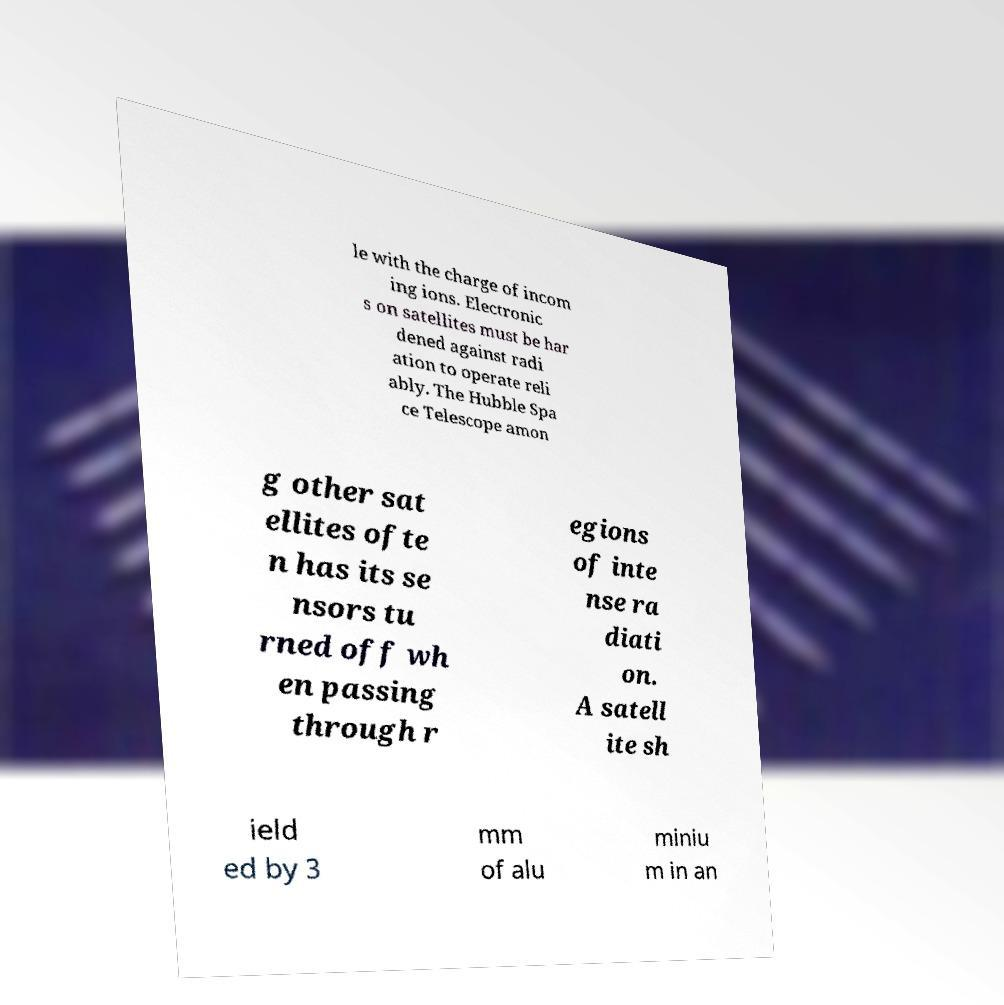Please read and relay the text visible in this image. What does it say? le with the charge of incom ing ions. Electronic s on satellites must be har dened against radi ation to operate reli ably. The Hubble Spa ce Telescope amon g other sat ellites ofte n has its se nsors tu rned off wh en passing through r egions of inte nse ra diati on. A satell ite sh ield ed by 3 mm of alu miniu m in an 